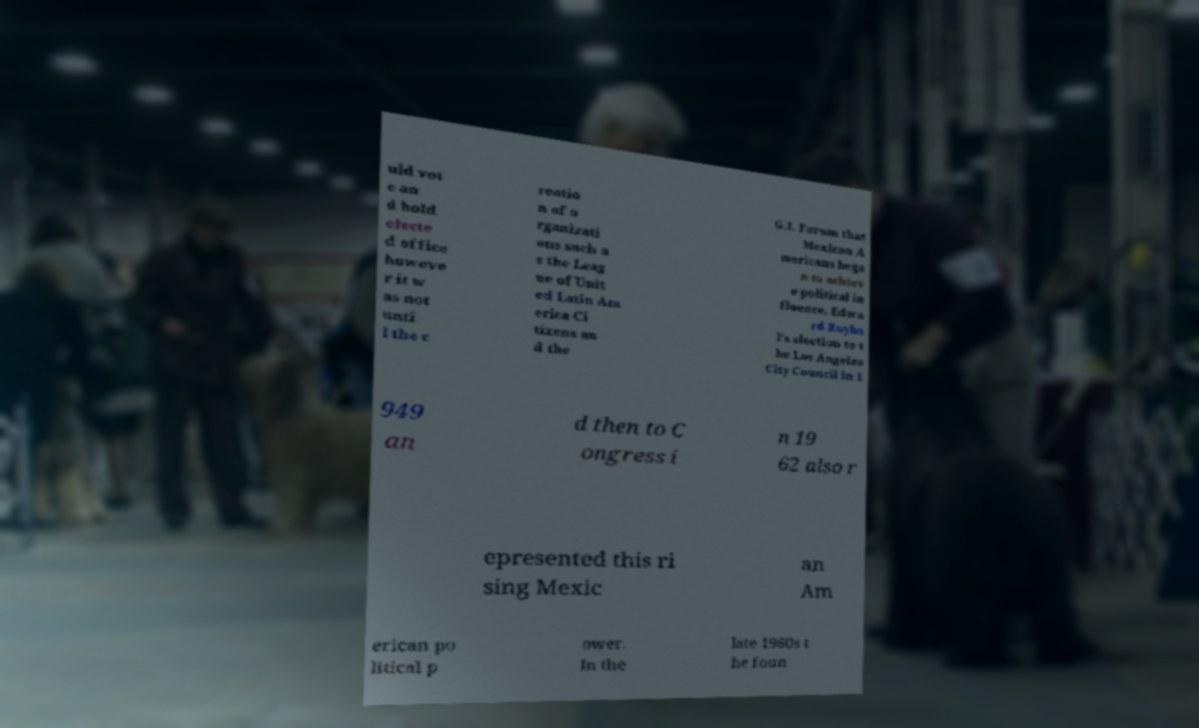What messages or text are displayed in this image? I need them in a readable, typed format. uld vot e an d hold electe d office howeve r it w as not unti l the c reatio n of o rganizati ons such a s the Leag ue of Unit ed Latin Am erica Ci tizens an d the G.I. Forum that Mexican A mericans bega n to achiev e political in fluence. Edwa rd Royba l's election to t he Los Angeles City Council in 1 949 an d then to C ongress i n 19 62 also r epresented this ri sing Mexic an Am erican po litical p ower. In the late 1960s t he foun 